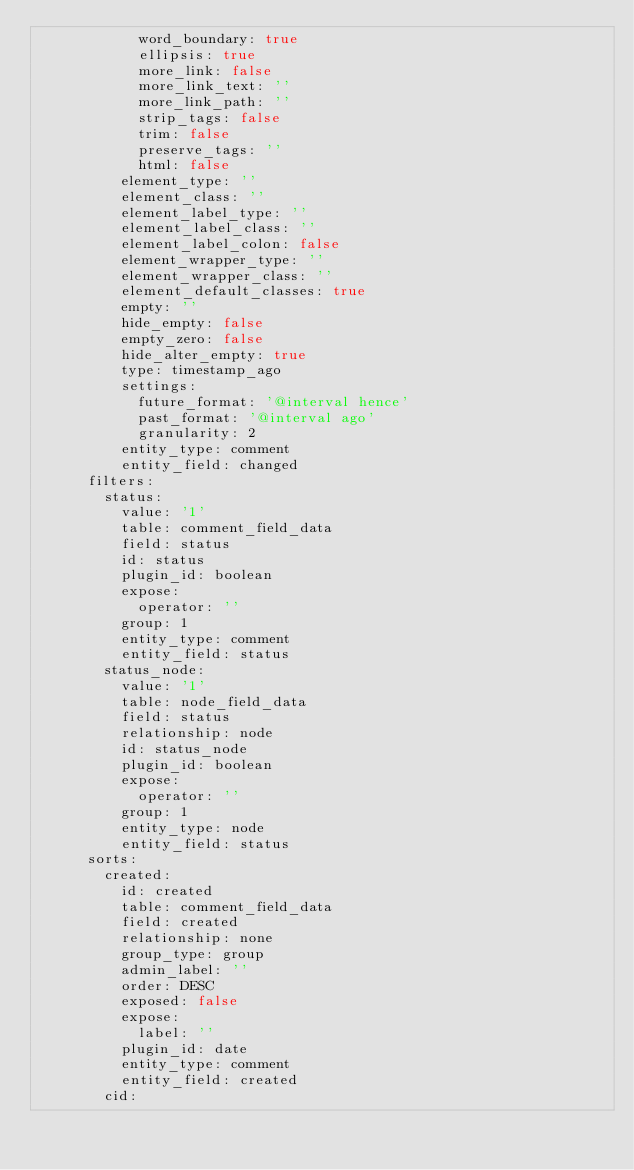Convert code to text. <code><loc_0><loc_0><loc_500><loc_500><_YAML_>            word_boundary: true
            ellipsis: true
            more_link: false
            more_link_text: ''
            more_link_path: ''
            strip_tags: false
            trim: false
            preserve_tags: ''
            html: false
          element_type: ''
          element_class: ''
          element_label_type: ''
          element_label_class: ''
          element_label_colon: false
          element_wrapper_type: ''
          element_wrapper_class: ''
          element_default_classes: true
          empty: ''
          hide_empty: false
          empty_zero: false
          hide_alter_empty: true
          type: timestamp_ago
          settings:
            future_format: '@interval hence'
            past_format: '@interval ago'
            granularity: 2
          entity_type: comment
          entity_field: changed
      filters:
        status:
          value: '1'
          table: comment_field_data
          field: status
          id: status
          plugin_id: boolean
          expose:
            operator: ''
          group: 1
          entity_type: comment
          entity_field: status
        status_node:
          value: '1'
          table: node_field_data
          field: status
          relationship: node
          id: status_node
          plugin_id: boolean
          expose:
            operator: ''
          group: 1
          entity_type: node
          entity_field: status
      sorts:
        created:
          id: created
          table: comment_field_data
          field: created
          relationship: none
          group_type: group
          admin_label: ''
          order: DESC
          exposed: false
          expose:
            label: ''
          plugin_id: date
          entity_type: comment
          entity_field: created
        cid:</code> 